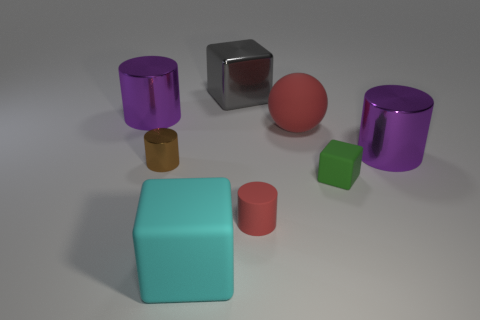What material is the ball that is the same color as the tiny rubber cylinder?
Provide a short and direct response. Rubber. There is another small object that is the same shape as the cyan matte object; what color is it?
Your response must be concise. Green. There is a matte object behind the brown thing; is it the same color as the big matte cube?
Keep it short and to the point. No. What shape is the small thing that is the same color as the large matte ball?
Keep it short and to the point. Cylinder. What number of big things have the same material as the brown cylinder?
Your answer should be compact. 3. What number of cubes are behind the large gray cube?
Keep it short and to the point. 0. What is the size of the green matte block?
Your response must be concise. Small. What is the color of the rubber object that is the same size as the red ball?
Make the answer very short. Cyan. Are there any large shiny blocks of the same color as the large sphere?
Ensure brevity in your answer.  No. What is the green object made of?
Ensure brevity in your answer.  Rubber. 